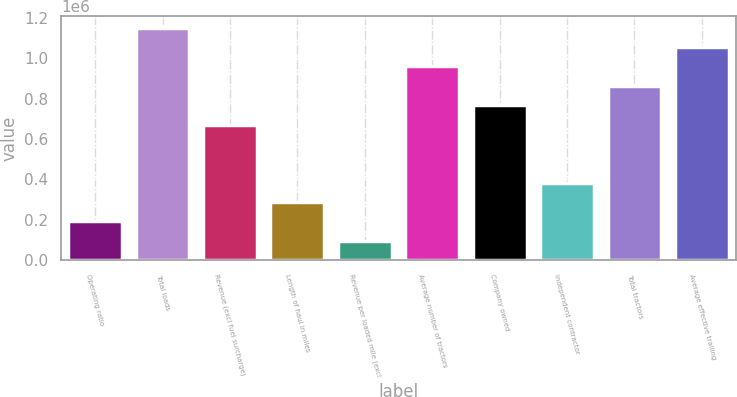<chart> <loc_0><loc_0><loc_500><loc_500><bar_chart><fcel>Operating ratio<fcel>Total loads<fcel>Revenue (excl fuel surcharge)<fcel>Length of haul in miles<fcel>Revenue per loaded mile (excl<fcel>Average number of tractors<fcel>Company owned<fcel>Independent contractor<fcel>Total tractors<fcel>Average effective trailing<nl><fcel>191911<fcel>1.15146e+06<fcel>671686<fcel>287866<fcel>95955.7<fcel>959551<fcel>767641<fcel>383821<fcel>863596<fcel>1.05551e+06<nl></chart> 